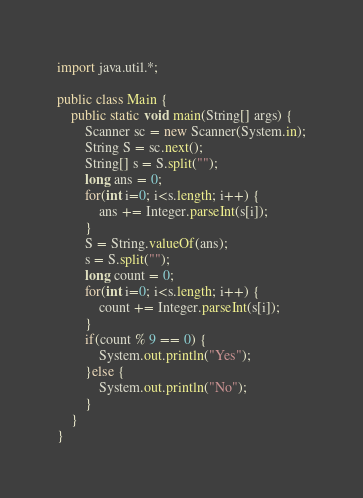<code> <loc_0><loc_0><loc_500><loc_500><_Java_>import java.util.*;

public class Main {
    public static void main(String[] args) {
        Scanner sc = new Scanner(System.in);
        String S = sc.next();
        String[] s = S.split("");
        long ans = 0;
        for(int i=0; i<s.length; i++) {
            ans += Integer.parseInt(s[i]);
        }
        S = String.valueOf(ans);
        s = S.split("");
        long count = 0;
        for(int i=0; i<s.length; i++) {
            count += Integer.parseInt(s[i]);
        }
        if(count % 9 == 0) {
            System.out.println("Yes");
        }else {
            System.out.println("No");
        }
    }
}
</code> 